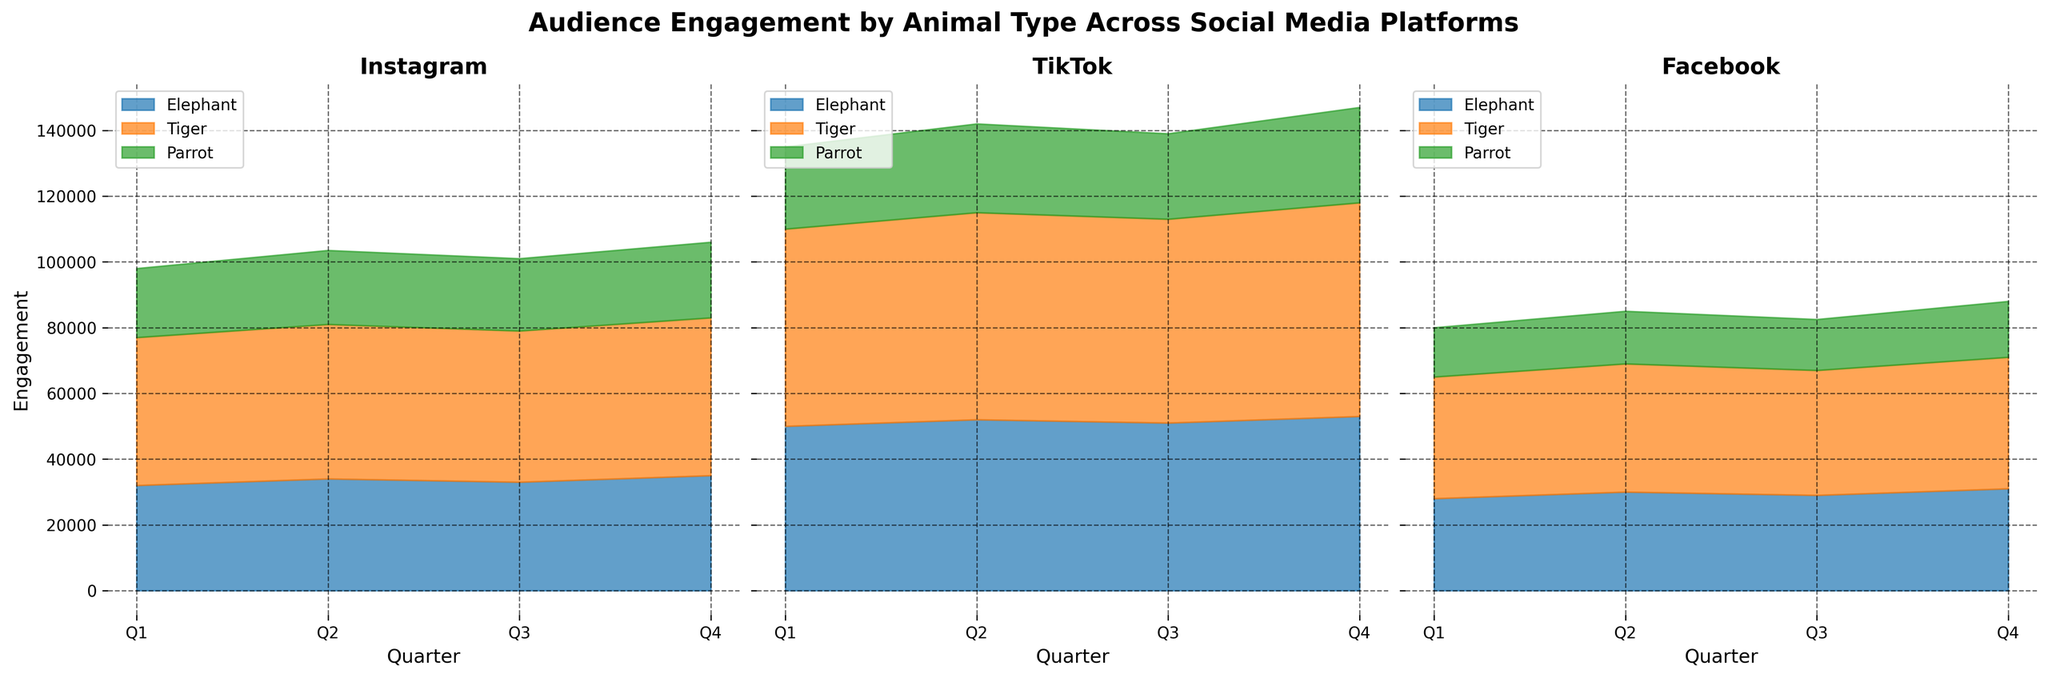What is the overall trend in engagement for elephants on TikTok throughout 2023? The engagement for elephants on TikTok shows an increasing trend. Starting from Q1 with 50,000 engagements, it rises steadily each quarter to reach 53,000 in Q4.
Answer: Increasing trend Which animal has the highest engagement on Instagram in Q2 2023? Comparing the engagement values for each animal on Instagram for Q2 2023, the tiger leads with 47,000 engagements.
Answer: Tiger How does the engagement for parrots on Facebook change from Q1 to Q4 in 2023? The engagement for parrots on Facebook increases steadily from 15,000 in Q1 to 17,000 in Q4.
Answer: Increasing What is the total engagement for tigers across all platforms in Q3 2023? Summing up tigers' engagement in Q3 2023: Instagram (46,000) + TikTok (62,000) + Facebook (38,000), results in a total of 146,000.
Answer: 146,000 Compare the engagement trends for elephants on Instagram and TikTok throughout 2023. Elephants' engagement on Instagram starts at 32,000 in Q1 and rises to 35,000 in Q4, while on TikTok, it starts higher at 50,000 and consistently grows to 53,000 by Q4. Both platforms show an increasing trend but with higher values on TikTok.
Answer: Both increasing, higher on TikTok Which platform has the highest total engagement for all animals in Q4 2023? Summing the engagements for all animals in Q4 2023: Instagram (35,000 + 48,000 + 23,000) = 106,000, TikTok (53,000 + 65,000 + 29,000) = 147,000, and Facebook (31,000 + 40,000 + 17,000) = 88,000. TikTok has the highest total.
Answer: TikTok What is the difference in engagement for tigers between Q1 and Q4 on Facebook in 2023? The engagement for tigers on Facebook in Q1 is 37,000 and in Q4 is 40,000. The difference is 40,000 - 37,000 = 3,000.
Answer: 3,000 